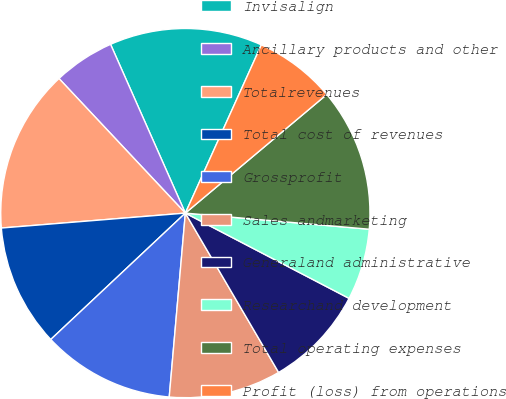<chart> <loc_0><loc_0><loc_500><loc_500><pie_chart><fcel>Invisalign<fcel>Ancillary products and other<fcel>Totalrevenues<fcel>Total cost of revenues<fcel>Grossprofit<fcel>Sales andmarketing<fcel>Generaland administrative<fcel>Researchand development<fcel>Total operating expenses<fcel>Profit (loss) from operations<nl><fcel>13.39%<fcel>5.36%<fcel>14.29%<fcel>10.71%<fcel>11.61%<fcel>9.82%<fcel>8.93%<fcel>6.25%<fcel>12.5%<fcel>7.14%<nl></chart> 